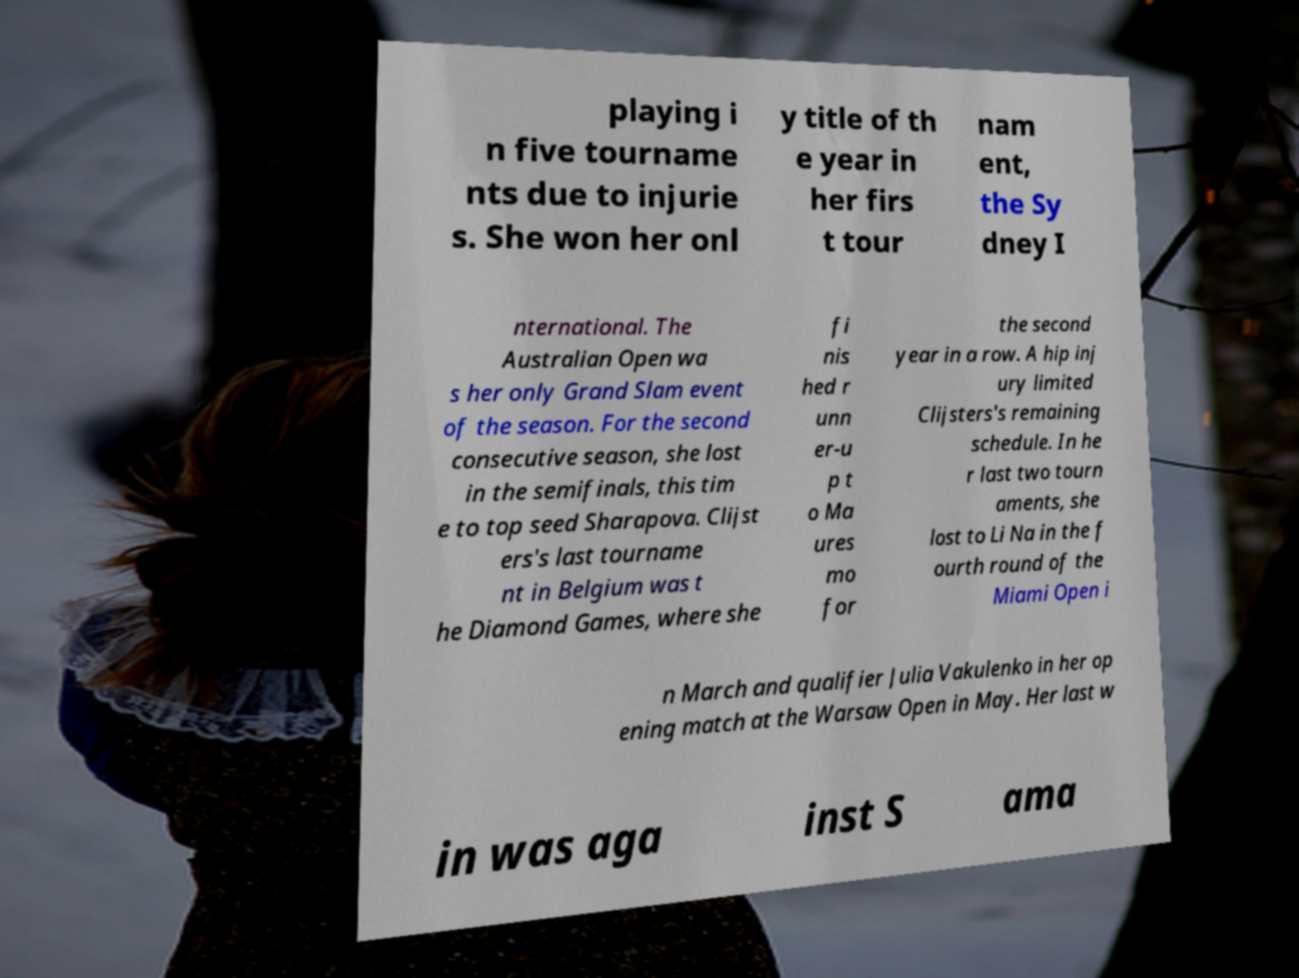Can you read and provide the text displayed in the image?This photo seems to have some interesting text. Can you extract and type it out for me? playing i n five tourname nts due to injurie s. She won her onl y title of th e year in her firs t tour nam ent, the Sy dney I nternational. The Australian Open wa s her only Grand Slam event of the season. For the second consecutive season, she lost in the semifinals, this tim e to top seed Sharapova. Clijst ers's last tourname nt in Belgium was t he Diamond Games, where she fi nis hed r unn er-u p t o Ma ures mo for the second year in a row. A hip inj ury limited Clijsters's remaining schedule. In he r last two tourn aments, she lost to Li Na in the f ourth round of the Miami Open i n March and qualifier Julia Vakulenko in her op ening match at the Warsaw Open in May. Her last w in was aga inst S ama 